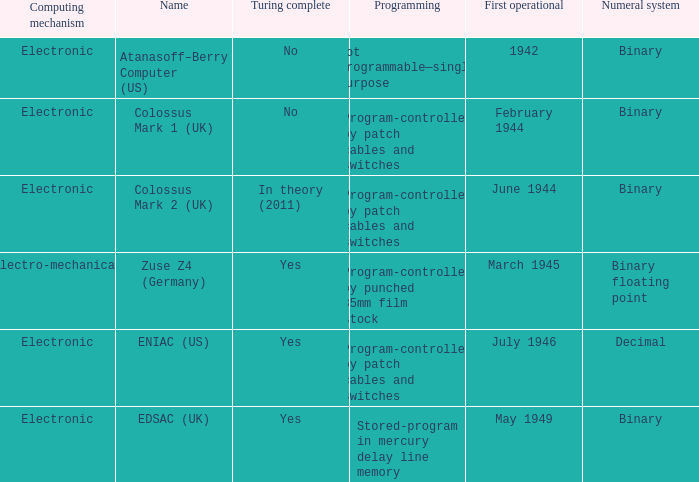What's the computing mechanbeingm with first operational being february 1944 Electronic. 